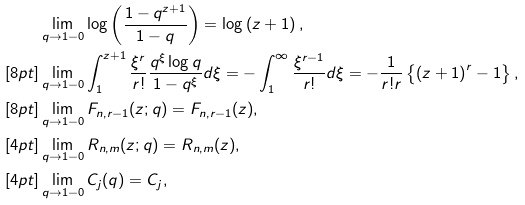Convert formula to latex. <formula><loc_0><loc_0><loc_500><loc_500>& \lim _ { q \to 1 - 0 } \log \left ( \frac { 1 - q ^ { z + 1 } } { 1 - q } \right ) = \log \left ( z + 1 \right ) , \\ [ 8 p t ] & \lim _ { q \to 1 - 0 } \int _ { 1 } ^ { z + 1 } \frac { \xi ^ { r } } { r ! } \frac { q ^ { \xi } \log q } { 1 - q ^ { \xi } } d \xi = - \int _ { 1 } ^ { \infty } \frac { \xi ^ { r - 1 } } { r ! } d \xi = - \frac { 1 } { r ! r } \left \{ \left ( z + 1 \right ) ^ { r } - 1 \right \} , \\ [ 8 p t ] & \lim _ { q \to 1 - 0 } F _ { n , r - 1 } ( z ; q ) = F _ { n , r - 1 } ( z ) , \\ [ 4 p t ] & \lim _ { q \to 1 - 0 } R _ { n , m } ( z ; q ) = R _ { n , m } ( z ) , \\ [ 4 p t ] & \lim _ { q \to 1 - 0 } C _ { j } ( q ) = C _ { j } ,</formula> 